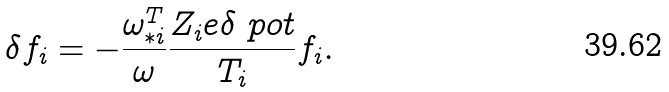<formula> <loc_0><loc_0><loc_500><loc_500>\delta f _ { i } = - \frac { \omega _ { * i } ^ { T } } { \omega } \frac { Z _ { i } e \delta \ p o t } { T _ { i } } f _ { i } .</formula> 